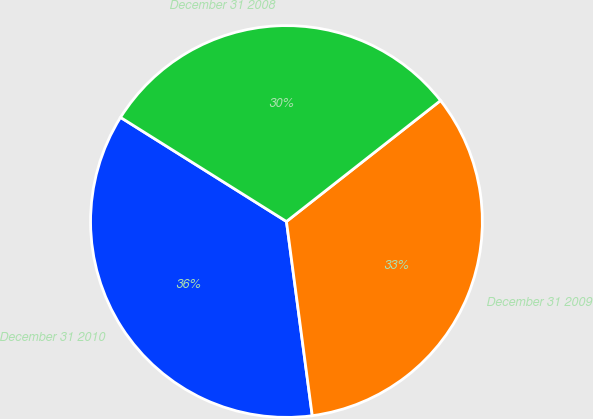Convert chart. <chart><loc_0><loc_0><loc_500><loc_500><pie_chart><fcel>December 31 2010<fcel>December 31 2009<fcel>December 31 2008<nl><fcel>36.02%<fcel>33.49%<fcel>30.49%<nl></chart> 